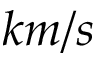Convert formula to latex. <formula><loc_0><loc_0><loc_500><loc_500>k m / s</formula> 